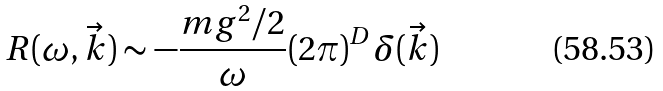Convert formula to latex. <formula><loc_0><loc_0><loc_500><loc_500>R ( \omega , \vec { k } ) \sim - \frac { m g ^ { 2 } / 2 } { \omega } ( 2 \pi ) ^ { D } \delta ( \vec { k } )</formula> 